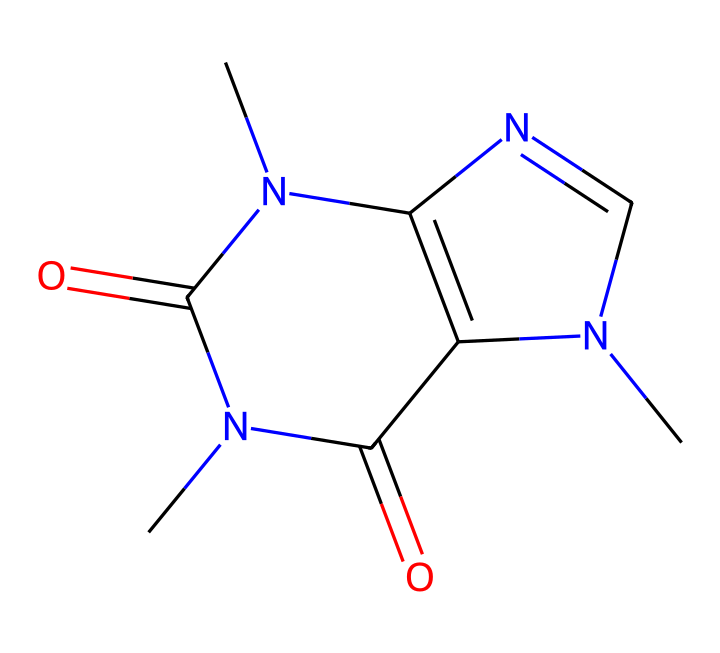What is the molecular formula of caffeine? The SMILES representation can be analyzed to identify the constituent atoms. The representation CN1C=NC2=C1C(=O)N(C(=O)N2C)C showcases the presence of Carbon (C), Hydrogen (H), Nitrogen (N), and Oxygen (O) atoms. Counting these, we determine that the molecular formula is C8H10N4O2.
Answer: C8H10N4O2 How many nitrogen atoms are present in caffeine's structure? By examining the SMILES code, we can identify and count the nitrogen (N) atoms based on their occurrences in the formula. In this case, there are four nitrogen atoms present in the caffeine structure.
Answer: 4 Is caffeine an aromatic compound? Aromatic compounds are characterized by a ring structure and delocalized pi electrons. From the provided SMILES, we notice a cyclic structure with satisfying Huckel's rule, confirming caffeine is indeed aromatic.
Answer: Yes What functional groups are present in caffeine? Analyzing the SMILES representation reveals multiple functional groups: the carbonyl group (C=O) observed in the ketones and the amine group (-NH) attached to the aromatic ring. Therefore, caffeine contains both amines and carbonyl functional groups.
Answer: amine and carbonyl What type of ring structure does caffeine have? Reviewing the structural representation, we can determine that caffeine possesses a fused bicyclic ring structure, which involves two interconnected rings. This is a characteristic feature in many alkaloids, to which caffeine belongs.
Answer: bicyclic How many total rings are present in the caffeine structure? By examining the rings formed in the caffeine structure through the SMILES notation, we find two interconnected rings that form the basis of its aromatic characteristics. Thus, the total number of rings is two.
Answer: 2 What is the significance of the nitrogen heteroatoms in caffeine? The presence of nitrogen heteroatoms in caffeine plays a crucial role in its basic functionality and biological activity, which is vital for its stimulant effects in coffee. The nitrogen atoms contribute to the compound being an alkaloid category known to affect neurotransmitter activity.
Answer: basic functionality and biological activity 